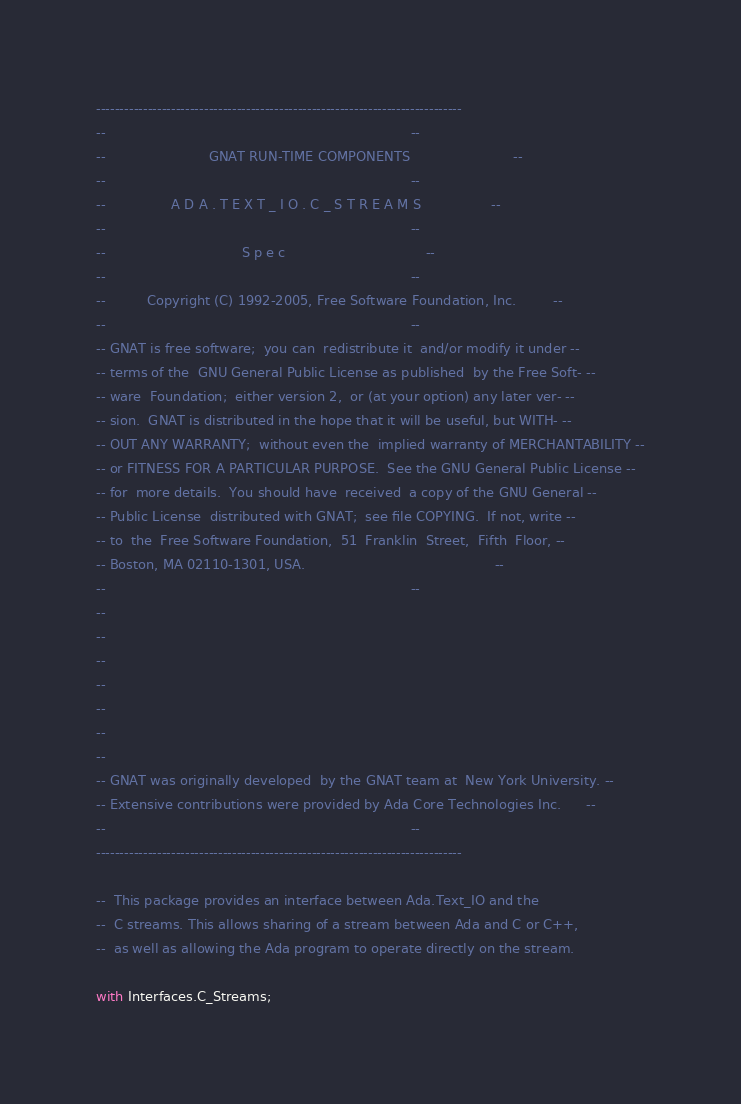Convert code to text. <code><loc_0><loc_0><loc_500><loc_500><_Ada_>------------------------------------------------------------------------------
--                                                                          --
--                         GNAT RUN-TIME COMPONENTS                         --
--                                                                          --
--                A D A . T E X T _ I O . C _ S T R E A M S                 --
--                                                                          --
--                                 S p e c                                  --
--                                                                          --
--          Copyright (C) 1992-2005, Free Software Foundation, Inc.         --
--                                                                          --
-- GNAT is free software;  you can  redistribute it  and/or modify it under --
-- terms of the  GNU General Public License as published  by the Free Soft- --
-- ware  Foundation;  either version 2,  or (at your option) any later ver- --
-- sion.  GNAT is distributed in the hope that it will be useful, but WITH- --
-- OUT ANY WARRANTY;  without even the  implied warranty of MERCHANTABILITY --
-- or FITNESS FOR A PARTICULAR PURPOSE.  See the GNU General Public License --
-- for  more details.  You should have  received  a copy of the GNU General --
-- Public License  distributed with GNAT;  see file COPYING.  If not, write --
-- to  the  Free Software Foundation,  51  Franklin  Street,  Fifth  Floor, --
-- Boston, MA 02110-1301, USA.                                              --
--                                                                          --
--
--
--
--
--
--
--
-- GNAT was originally developed  by the GNAT team at  New York University. --
-- Extensive contributions were provided by Ada Core Technologies Inc.      --
--                                                                          --
------------------------------------------------------------------------------

--  This package provides an interface between Ada.Text_IO and the
--  C streams. This allows sharing of a stream between Ada and C or C++,
--  as well as allowing the Ada program to operate directly on the stream.

with Interfaces.C_Streams;
</code> 